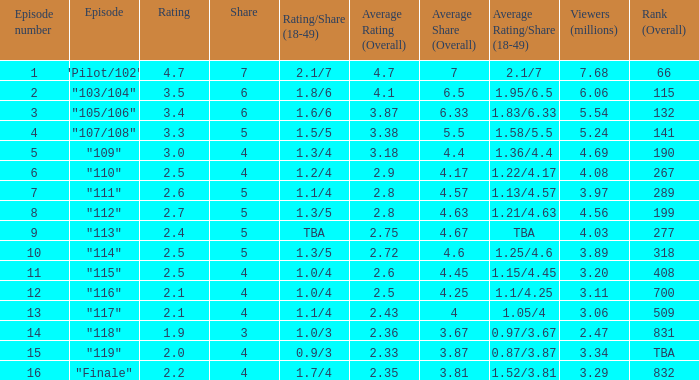WHAT IS THE NUMBER OF VIEWERS WITH EPISODE LARGER THAN 10, RATING SMALLER THAN 2? 2.47. 